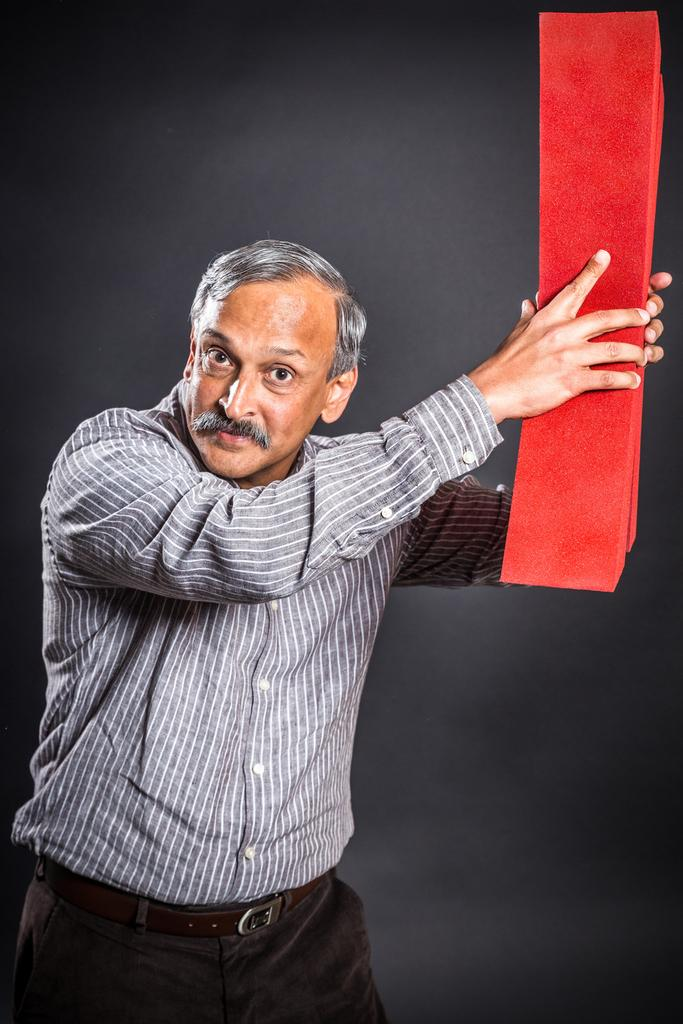What is present in the image? There is a person in the image. What is the person doing in the image? The person is holding an object in their hand. What type of bead is the person wearing around their neck in the image? There is no bead visible around the person's neck in the image. What type of breakfast is the person eating in the image? There is no breakfast present in the image; the person is only holding an object in their hand. 